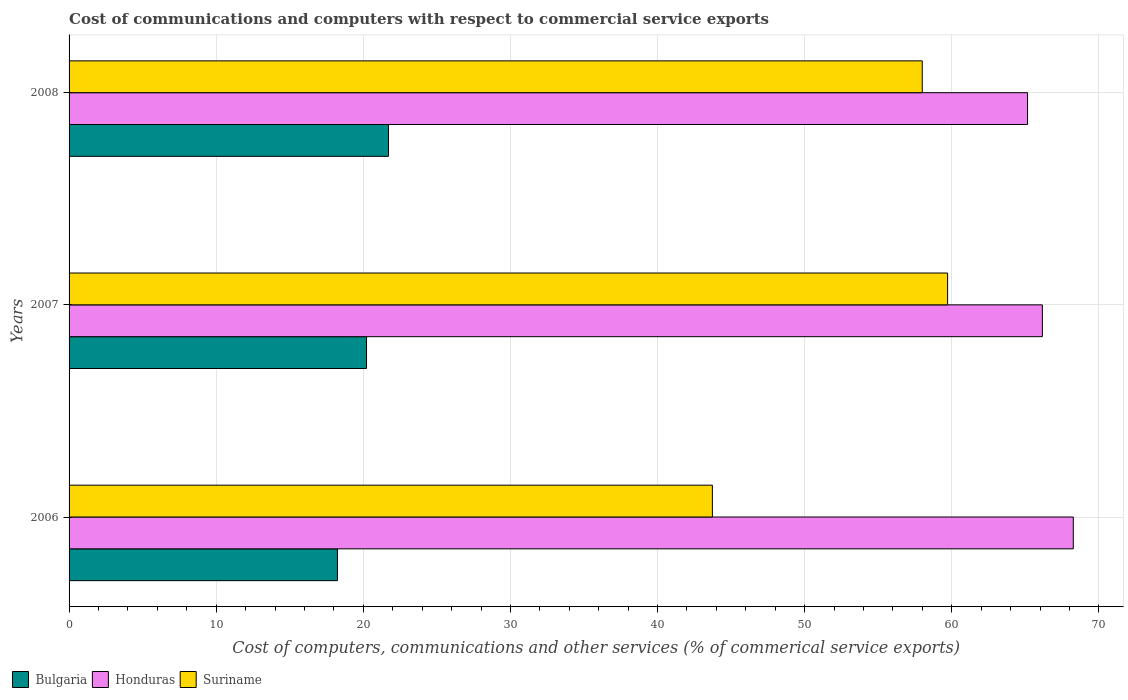How many bars are there on the 3rd tick from the top?
Your answer should be compact. 3. How many bars are there on the 3rd tick from the bottom?
Your answer should be very brief. 3. What is the label of the 2nd group of bars from the top?
Your answer should be compact. 2007. What is the cost of communications and computers in Bulgaria in 2007?
Your response must be concise. 20.22. Across all years, what is the maximum cost of communications and computers in Bulgaria?
Your answer should be very brief. 21.71. Across all years, what is the minimum cost of communications and computers in Honduras?
Offer a terse response. 65.15. In which year was the cost of communications and computers in Bulgaria maximum?
Offer a terse response. 2008. In which year was the cost of communications and computers in Suriname minimum?
Keep it short and to the point. 2006. What is the total cost of communications and computers in Honduras in the graph?
Give a very brief answer. 199.56. What is the difference between the cost of communications and computers in Bulgaria in 2006 and that in 2008?
Give a very brief answer. -3.47. What is the difference between the cost of communications and computers in Honduras in 2008 and the cost of communications and computers in Suriname in 2007?
Offer a terse response. 5.43. What is the average cost of communications and computers in Bulgaria per year?
Offer a very short reply. 20.06. In the year 2006, what is the difference between the cost of communications and computers in Honduras and cost of communications and computers in Bulgaria?
Provide a short and direct response. 50.02. What is the ratio of the cost of communications and computers in Suriname in 2007 to that in 2008?
Provide a succinct answer. 1.03. Is the cost of communications and computers in Bulgaria in 2007 less than that in 2008?
Ensure brevity in your answer.  Yes. Is the difference between the cost of communications and computers in Honduras in 2006 and 2008 greater than the difference between the cost of communications and computers in Bulgaria in 2006 and 2008?
Your answer should be very brief. Yes. What is the difference between the highest and the second highest cost of communications and computers in Bulgaria?
Offer a very short reply. 1.49. What is the difference between the highest and the lowest cost of communications and computers in Suriname?
Your answer should be compact. 15.99. In how many years, is the cost of communications and computers in Suriname greater than the average cost of communications and computers in Suriname taken over all years?
Provide a succinct answer. 2. Is it the case that in every year, the sum of the cost of communications and computers in Honduras and cost of communications and computers in Bulgaria is greater than the cost of communications and computers in Suriname?
Provide a succinct answer. Yes. What is the difference between two consecutive major ticks on the X-axis?
Provide a short and direct response. 10. Are the values on the major ticks of X-axis written in scientific E-notation?
Your answer should be very brief. No. What is the title of the graph?
Your answer should be compact. Cost of communications and computers with respect to commercial service exports. Does "Bulgaria" appear as one of the legend labels in the graph?
Your answer should be very brief. Yes. What is the label or title of the X-axis?
Offer a very short reply. Cost of computers, communications and other services (% of commerical service exports). What is the Cost of computers, communications and other services (% of commerical service exports) in Bulgaria in 2006?
Your answer should be very brief. 18.24. What is the Cost of computers, communications and other services (% of commerical service exports) in Honduras in 2006?
Give a very brief answer. 68.26. What is the Cost of computers, communications and other services (% of commerical service exports) in Suriname in 2006?
Your answer should be compact. 43.73. What is the Cost of computers, communications and other services (% of commerical service exports) of Bulgaria in 2007?
Provide a short and direct response. 20.22. What is the Cost of computers, communications and other services (% of commerical service exports) of Honduras in 2007?
Offer a terse response. 66.16. What is the Cost of computers, communications and other services (% of commerical service exports) of Suriname in 2007?
Provide a short and direct response. 59.72. What is the Cost of computers, communications and other services (% of commerical service exports) in Bulgaria in 2008?
Offer a very short reply. 21.71. What is the Cost of computers, communications and other services (% of commerical service exports) in Honduras in 2008?
Make the answer very short. 65.15. What is the Cost of computers, communications and other services (% of commerical service exports) in Suriname in 2008?
Provide a succinct answer. 57.99. Across all years, what is the maximum Cost of computers, communications and other services (% of commerical service exports) in Bulgaria?
Your response must be concise. 21.71. Across all years, what is the maximum Cost of computers, communications and other services (% of commerical service exports) of Honduras?
Offer a very short reply. 68.26. Across all years, what is the maximum Cost of computers, communications and other services (% of commerical service exports) of Suriname?
Provide a short and direct response. 59.72. Across all years, what is the minimum Cost of computers, communications and other services (% of commerical service exports) in Bulgaria?
Offer a terse response. 18.24. Across all years, what is the minimum Cost of computers, communications and other services (% of commerical service exports) in Honduras?
Your response must be concise. 65.15. Across all years, what is the minimum Cost of computers, communications and other services (% of commerical service exports) in Suriname?
Keep it short and to the point. 43.73. What is the total Cost of computers, communications and other services (% of commerical service exports) of Bulgaria in the graph?
Offer a terse response. 60.17. What is the total Cost of computers, communications and other services (% of commerical service exports) of Honduras in the graph?
Your response must be concise. 199.56. What is the total Cost of computers, communications and other services (% of commerical service exports) of Suriname in the graph?
Your answer should be compact. 161.44. What is the difference between the Cost of computers, communications and other services (% of commerical service exports) of Bulgaria in 2006 and that in 2007?
Ensure brevity in your answer.  -1.98. What is the difference between the Cost of computers, communications and other services (% of commerical service exports) of Honduras in 2006 and that in 2007?
Ensure brevity in your answer.  2.1. What is the difference between the Cost of computers, communications and other services (% of commerical service exports) in Suriname in 2006 and that in 2007?
Make the answer very short. -15.99. What is the difference between the Cost of computers, communications and other services (% of commerical service exports) in Bulgaria in 2006 and that in 2008?
Provide a succinct answer. -3.47. What is the difference between the Cost of computers, communications and other services (% of commerical service exports) in Honduras in 2006 and that in 2008?
Ensure brevity in your answer.  3.11. What is the difference between the Cost of computers, communications and other services (% of commerical service exports) of Suriname in 2006 and that in 2008?
Make the answer very short. -14.27. What is the difference between the Cost of computers, communications and other services (% of commerical service exports) of Bulgaria in 2007 and that in 2008?
Offer a terse response. -1.49. What is the difference between the Cost of computers, communications and other services (% of commerical service exports) of Honduras in 2007 and that in 2008?
Your answer should be compact. 1.01. What is the difference between the Cost of computers, communications and other services (% of commerical service exports) of Suriname in 2007 and that in 2008?
Your answer should be compact. 1.72. What is the difference between the Cost of computers, communications and other services (% of commerical service exports) in Bulgaria in 2006 and the Cost of computers, communications and other services (% of commerical service exports) in Honduras in 2007?
Offer a very short reply. -47.92. What is the difference between the Cost of computers, communications and other services (% of commerical service exports) in Bulgaria in 2006 and the Cost of computers, communications and other services (% of commerical service exports) in Suriname in 2007?
Provide a succinct answer. -41.48. What is the difference between the Cost of computers, communications and other services (% of commerical service exports) of Honduras in 2006 and the Cost of computers, communications and other services (% of commerical service exports) of Suriname in 2007?
Provide a succinct answer. 8.54. What is the difference between the Cost of computers, communications and other services (% of commerical service exports) of Bulgaria in 2006 and the Cost of computers, communications and other services (% of commerical service exports) of Honduras in 2008?
Provide a short and direct response. -46.91. What is the difference between the Cost of computers, communications and other services (% of commerical service exports) of Bulgaria in 2006 and the Cost of computers, communications and other services (% of commerical service exports) of Suriname in 2008?
Provide a succinct answer. -39.75. What is the difference between the Cost of computers, communications and other services (% of commerical service exports) in Honduras in 2006 and the Cost of computers, communications and other services (% of commerical service exports) in Suriname in 2008?
Your answer should be very brief. 10.27. What is the difference between the Cost of computers, communications and other services (% of commerical service exports) of Bulgaria in 2007 and the Cost of computers, communications and other services (% of commerical service exports) of Honduras in 2008?
Keep it short and to the point. -44.93. What is the difference between the Cost of computers, communications and other services (% of commerical service exports) of Bulgaria in 2007 and the Cost of computers, communications and other services (% of commerical service exports) of Suriname in 2008?
Your answer should be very brief. -37.77. What is the difference between the Cost of computers, communications and other services (% of commerical service exports) in Honduras in 2007 and the Cost of computers, communications and other services (% of commerical service exports) in Suriname in 2008?
Offer a terse response. 8.16. What is the average Cost of computers, communications and other services (% of commerical service exports) of Bulgaria per year?
Your answer should be very brief. 20.06. What is the average Cost of computers, communications and other services (% of commerical service exports) in Honduras per year?
Your answer should be very brief. 66.52. What is the average Cost of computers, communications and other services (% of commerical service exports) of Suriname per year?
Make the answer very short. 53.81. In the year 2006, what is the difference between the Cost of computers, communications and other services (% of commerical service exports) of Bulgaria and Cost of computers, communications and other services (% of commerical service exports) of Honduras?
Give a very brief answer. -50.02. In the year 2006, what is the difference between the Cost of computers, communications and other services (% of commerical service exports) in Bulgaria and Cost of computers, communications and other services (% of commerical service exports) in Suriname?
Give a very brief answer. -25.49. In the year 2006, what is the difference between the Cost of computers, communications and other services (% of commerical service exports) of Honduras and Cost of computers, communications and other services (% of commerical service exports) of Suriname?
Give a very brief answer. 24.53. In the year 2007, what is the difference between the Cost of computers, communications and other services (% of commerical service exports) in Bulgaria and Cost of computers, communications and other services (% of commerical service exports) in Honduras?
Your answer should be compact. -45.94. In the year 2007, what is the difference between the Cost of computers, communications and other services (% of commerical service exports) of Bulgaria and Cost of computers, communications and other services (% of commerical service exports) of Suriname?
Offer a terse response. -39.5. In the year 2007, what is the difference between the Cost of computers, communications and other services (% of commerical service exports) of Honduras and Cost of computers, communications and other services (% of commerical service exports) of Suriname?
Offer a very short reply. 6.44. In the year 2008, what is the difference between the Cost of computers, communications and other services (% of commerical service exports) of Bulgaria and Cost of computers, communications and other services (% of commerical service exports) of Honduras?
Offer a terse response. -43.44. In the year 2008, what is the difference between the Cost of computers, communications and other services (% of commerical service exports) of Bulgaria and Cost of computers, communications and other services (% of commerical service exports) of Suriname?
Offer a very short reply. -36.28. In the year 2008, what is the difference between the Cost of computers, communications and other services (% of commerical service exports) of Honduras and Cost of computers, communications and other services (% of commerical service exports) of Suriname?
Provide a succinct answer. 7.16. What is the ratio of the Cost of computers, communications and other services (% of commerical service exports) in Bulgaria in 2006 to that in 2007?
Make the answer very short. 0.9. What is the ratio of the Cost of computers, communications and other services (% of commerical service exports) of Honduras in 2006 to that in 2007?
Your answer should be compact. 1.03. What is the ratio of the Cost of computers, communications and other services (% of commerical service exports) in Suriname in 2006 to that in 2007?
Provide a succinct answer. 0.73. What is the ratio of the Cost of computers, communications and other services (% of commerical service exports) of Bulgaria in 2006 to that in 2008?
Your response must be concise. 0.84. What is the ratio of the Cost of computers, communications and other services (% of commerical service exports) in Honduras in 2006 to that in 2008?
Offer a very short reply. 1.05. What is the ratio of the Cost of computers, communications and other services (% of commerical service exports) of Suriname in 2006 to that in 2008?
Ensure brevity in your answer.  0.75. What is the ratio of the Cost of computers, communications and other services (% of commerical service exports) of Bulgaria in 2007 to that in 2008?
Offer a terse response. 0.93. What is the ratio of the Cost of computers, communications and other services (% of commerical service exports) of Honduras in 2007 to that in 2008?
Your answer should be compact. 1.02. What is the ratio of the Cost of computers, communications and other services (% of commerical service exports) in Suriname in 2007 to that in 2008?
Offer a terse response. 1.03. What is the difference between the highest and the second highest Cost of computers, communications and other services (% of commerical service exports) of Bulgaria?
Give a very brief answer. 1.49. What is the difference between the highest and the second highest Cost of computers, communications and other services (% of commerical service exports) in Honduras?
Offer a very short reply. 2.1. What is the difference between the highest and the second highest Cost of computers, communications and other services (% of commerical service exports) of Suriname?
Offer a terse response. 1.72. What is the difference between the highest and the lowest Cost of computers, communications and other services (% of commerical service exports) in Bulgaria?
Keep it short and to the point. 3.47. What is the difference between the highest and the lowest Cost of computers, communications and other services (% of commerical service exports) of Honduras?
Provide a succinct answer. 3.11. What is the difference between the highest and the lowest Cost of computers, communications and other services (% of commerical service exports) of Suriname?
Your response must be concise. 15.99. 